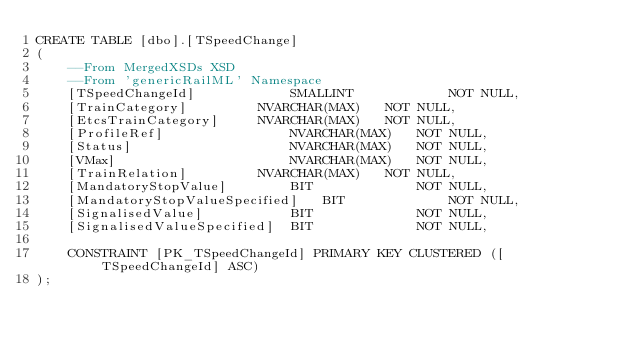Convert code to text. <code><loc_0><loc_0><loc_500><loc_500><_SQL_>CREATE TABLE [dbo].[TSpeedChange]
(
	--From MergedXSDs XSD
	--From 'genericRailML' Namespace
	[TSpeedChangeId]			SMALLINT			NOT NULL,
	[TrainCategory]			NVARCHAR(MAX)	NOT NULL,
	[EtcsTrainCategory]		NVARCHAR(MAX)	NOT NULL,
	[ProfileRef]				NVARCHAR(MAX)	NOT NULL,
	[Status]					NVARCHAR(MAX)	NOT NULL,
	[VMax]						NVARCHAR(MAX)	NOT NULL,
	[TrainRelation]			NVARCHAR(MAX)	NOT NULL,
	[MandatoryStopValue]		BIT				NOT NULL,
	[MandatoryStopValueSpecified]	BIT				NOT NULL,
	[SignalisedValue]			BIT				NOT NULL,
	[SignalisedValueSpecified]	BIT				NOT NULL,

	CONSTRAINT [PK_TSpeedChangeId] PRIMARY KEY CLUSTERED ([TSpeedChangeId] ASC)
);
</code> 